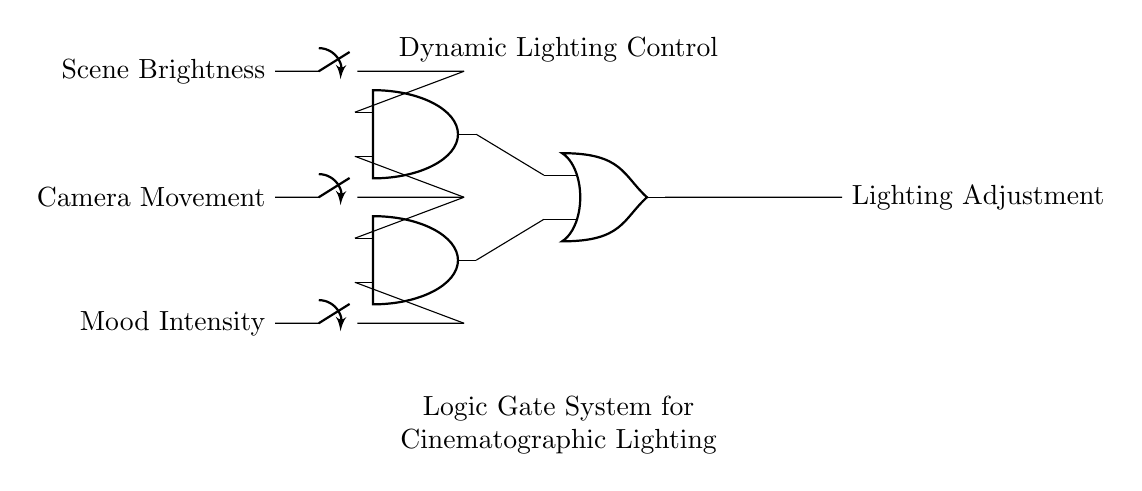What are the inputs to the circuit? The circuit has three inputs: Scene Brightness, Camera Movement, and Mood Intensity. Each of these inputs corresponds to a switch that can either be in an ON or OFF state, allowing for varying control signals.
Answer: Scene Brightness, Camera Movement, Mood Intensity What type of logic gates are used in this circuit? There are two AND gates and one OR gate in the circuit. The AND gates are responsible for processing combinations of inputs, while the OR gate combines the outputs of the AND gates to produce a final result.
Answer: AND, OR What is the output of the logic gate system? The output of the system is Lighting Adjustment, which is the final result derived from the processing of the input signals through the AND and OR gates.
Answer: Lighting Adjustment How many AND gates are present in the circuit? There are two AND gates present. Each AND gate links two different inputs to determine whether their combined condition allows for a signal to pass through to the OR gate.
Answer: 2 If all inputs are active, what will be the output? If all inputs are active, both AND gates will output a signal to the OR gate, which results in the output being active, thus lighting adjustment takes effect. Since both AND gates require at least two active inputs to produce a true output, with all inputs ON, the system is fully functional.
Answer: Active What is the function of the OR gate in this system? The OR gate receives outputs from both AND gates. Its function is to provide an output if at least one of the inputs it receives is active, thereby combining multiple input conditions into a single output that indicates a lighting adjustment based on any true condition detected.
Answer: Combine signals 